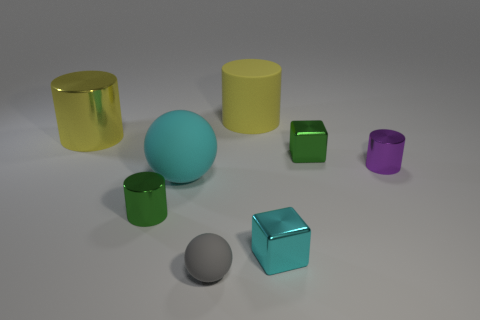Can you describe the lighting in the scene? The lighting in the image is soft and diffused, casting gentle shadows to the side of each object. There seems to be a primary light source above the objects, giving them a slight highlight on their upper surfaces and contributing to the overall calm ambiance of the scene. 